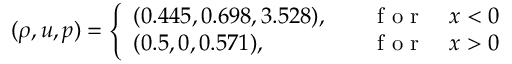Convert formula to latex. <formula><loc_0><loc_0><loc_500><loc_500>( \rho , u , p ) = \left \{ \begin{array} { l l } { ( 0 . 4 4 5 , 0 . 6 9 8 , 3 . 5 2 8 ) , \quad } & { f o r \quad x < 0 } \\ { ( 0 . 5 , 0 , 0 . 5 7 1 ) , \quad } & { f o r \quad x > 0 } \end{array}</formula> 